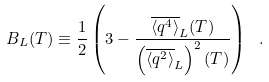<formula> <loc_0><loc_0><loc_500><loc_500>B _ { L } ( T ) \equiv \frac { 1 } { 2 } \left ( 3 - \frac { \overline { \langle q ^ { 4 } \rangle } _ { L } ( T ) } { \left ( \overline { \langle q ^ { 2 } \rangle } _ { L } \right ) ^ { 2 } ( T ) } \right ) \ .</formula> 